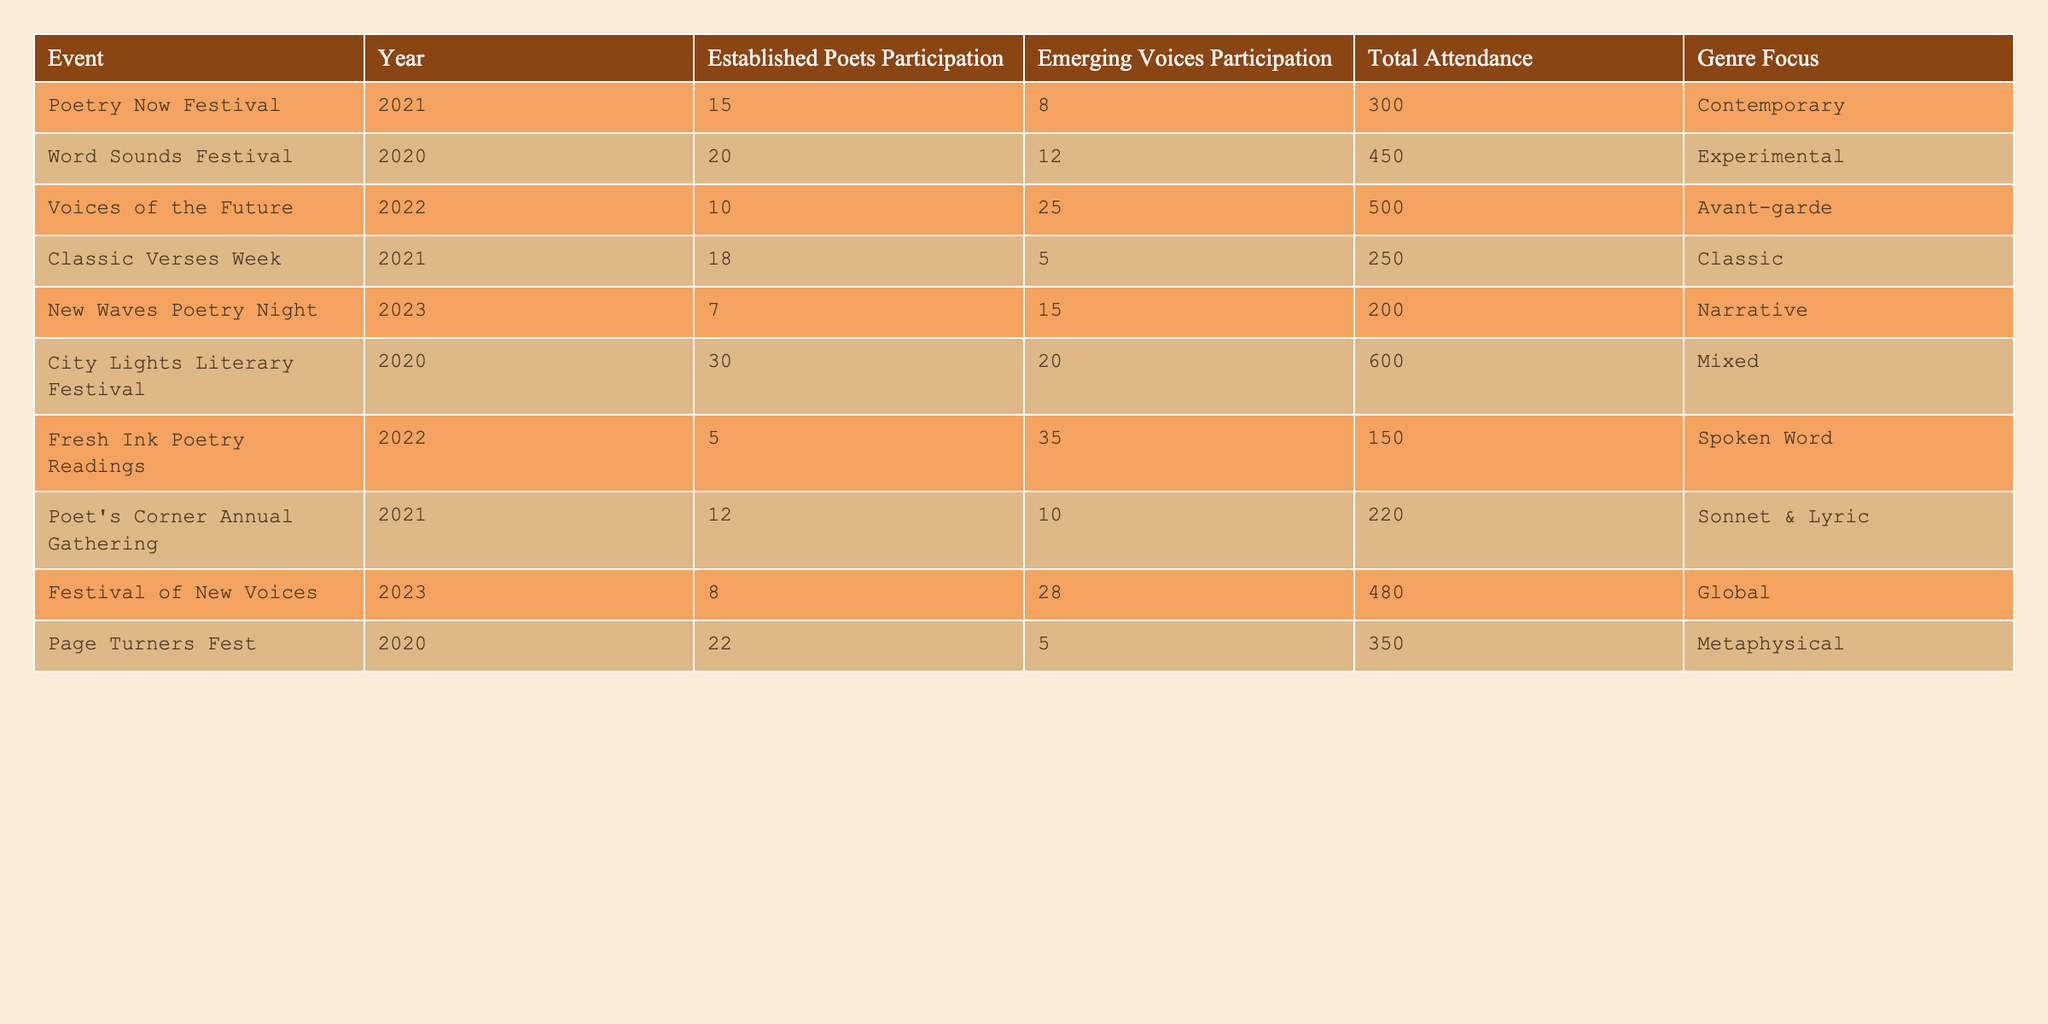What is the total attendance at the "City Lights Literary Festival"? The table shows the entry for the "City Lights Literary Festival" in the year 2020 with a total attendance of 600.
Answer: 600 How many established poets participated in the "Voices of the Future" event? From the table, it can be seen that in the "Voices of the Future" festival, 10 established poets participated in 2022.
Answer: 10 What is the difference in participation between established poets and emerging voices at the "Fresh Ink Poetry Readings"? At the "Fresh Ink Poetry Readings," 5 established poets participated while 35 emerging voices participated. The difference is 35 - 5 = 30.
Answer: 30 Which event had the highest participation of emerging voices, and what was that number? Reviewing the table, "Fresh Ink Poetry Readings" had the highest participation of emerging voices, with 35 participants.
Answer: 35 What is the average total attendance for all events listed in the table? Adding the total attendance numbers: 300 + 450 + 500 + 250 + 200 + 600 + 150 + 220 + 480 + 350 = 3100. There are 10 events, so the average total attendance is 3100 / 10 = 310.
Answer: 310 Are there more established poets or emerging voices at the "New Waves Poetry Night"? At this event, 7 established poets participated compared to 15 emerging voices, meaning there are more emerging voices.
Answer: Yes What event had the least participation from established poets and how many were there? The "Fresh Ink Poetry Readings" event in 2022 had the least participation, with only 5 established poets.
Answer: 5 Which genre had the highest total attendance and what was that attendance? The "City Lights Literary Festival" under the "Mixed" genre had the highest attendance at 600.
Answer: 600 What is the total participation of established poets across all events? By summing up the established poets' participation: 15 + 20 + 10 + 18 + 7 + 30 + 5 + 12 + 8 + 22 =  147.
Answer: 147 How does the participation of established poets in 2023 compare to their participation in 2020? In 2023, the total participation of established poets is 7, while in 2020, it's 20. The comparison shows a decrease of 13.
Answer: Decrease of 13 